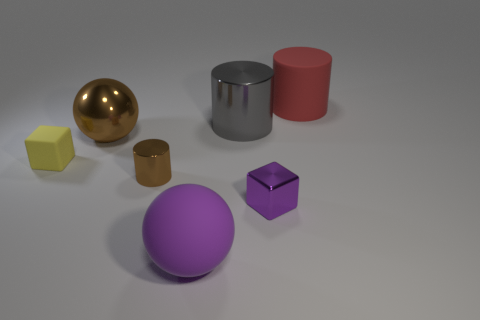Is the material of the large brown ball the same as the tiny cylinder?
Give a very brief answer. Yes. What number of purple cubes have the same material as the gray object?
Provide a short and direct response. 1. Does the rubber cube have the same size as the purple thing that is on the left side of the purple block?
Give a very brief answer. No. The big thing that is both behind the purple rubber object and on the left side of the gray thing is what color?
Ensure brevity in your answer.  Brown. There is a tiny object that is on the right side of the tiny brown thing; are there any small brown cylinders in front of it?
Offer a very short reply. No. Are there an equal number of small brown metal cylinders behind the big rubber cylinder and small cyan metal cylinders?
Your answer should be compact. Yes. There is a large metallic object behind the large ball behind the small brown metallic cylinder; what number of large matte things are to the left of it?
Offer a terse response. 1. Are there any brown cylinders that have the same size as the purple shiny block?
Provide a succinct answer. Yes. Is the number of matte things that are on the right side of the small yellow cube less than the number of large gray metal objects?
Offer a very short reply. No. There is a big cylinder in front of the cylinder that is right of the large cylinder that is in front of the red thing; what is its material?
Give a very brief answer. Metal. 